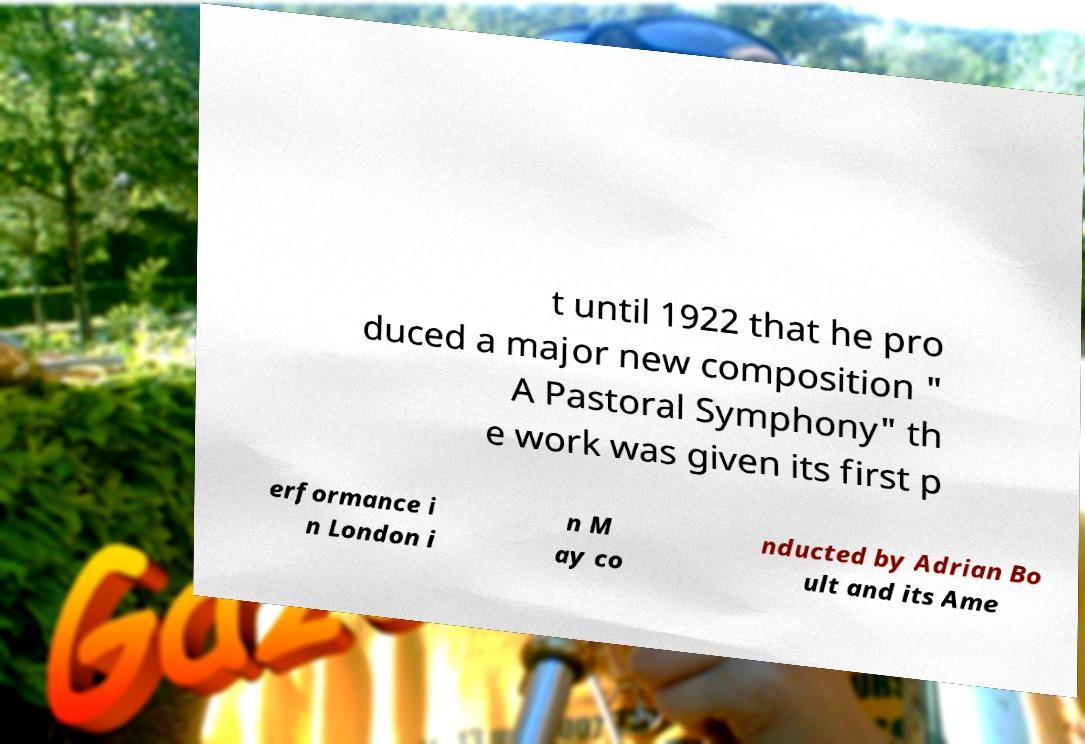I need the written content from this picture converted into text. Can you do that? t until 1922 that he pro duced a major new composition " A Pastoral Symphony" th e work was given its first p erformance i n London i n M ay co nducted by Adrian Bo ult and its Ame 